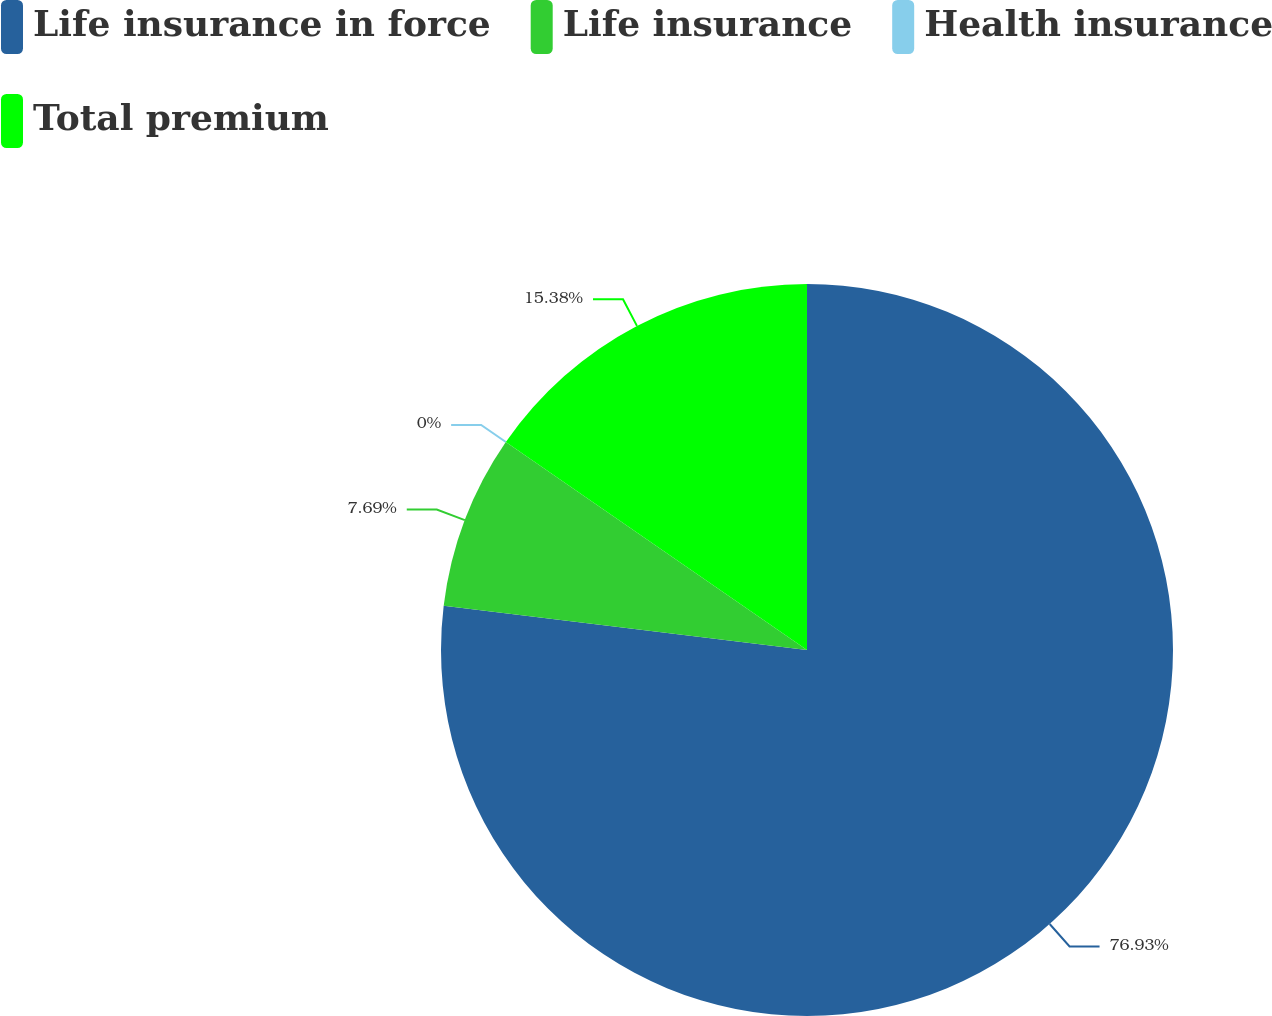<chart> <loc_0><loc_0><loc_500><loc_500><pie_chart><fcel>Life insurance in force<fcel>Life insurance<fcel>Health insurance<fcel>Total premium<nl><fcel>76.92%<fcel>7.69%<fcel>0.0%<fcel>15.38%<nl></chart> 